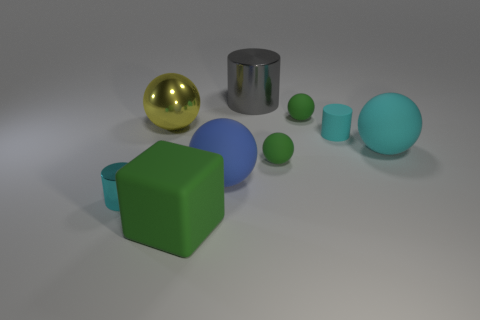Subtract all green spheres. How many were subtracted if there are1green spheres left? 1 Subtract all small metal cylinders. How many cylinders are left? 2 Subtract all green balls. How many cyan cylinders are left? 2 Subtract all green spheres. How many spheres are left? 3 Subtract 1 cylinders. How many cylinders are left? 2 Add 1 gray metal cylinders. How many objects exist? 10 Subtract all red spheres. Subtract all brown cylinders. How many spheres are left? 5 Add 6 cyan rubber cylinders. How many cyan rubber cylinders are left? 7 Add 4 large shiny balls. How many large shiny balls exist? 5 Subtract 1 yellow spheres. How many objects are left? 8 